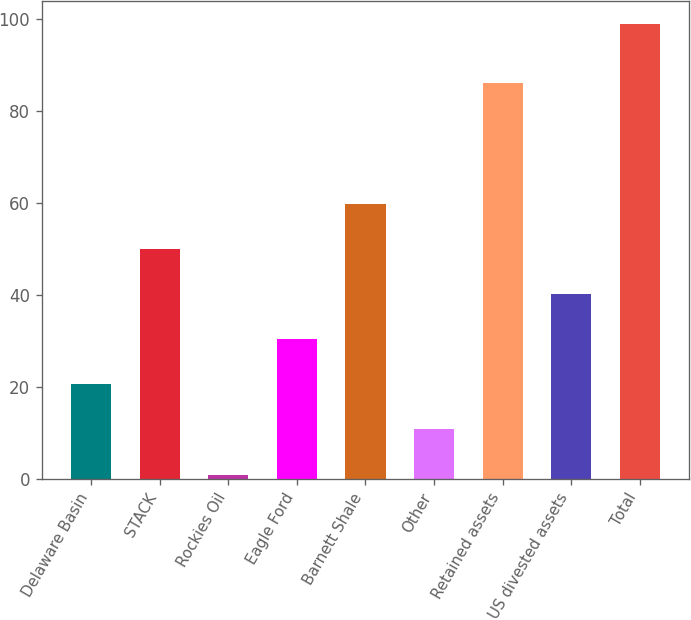Convert chart to OTSL. <chart><loc_0><loc_0><loc_500><loc_500><bar_chart><fcel>Delaware Basin<fcel>STACK<fcel>Rockies Oil<fcel>Eagle Ford<fcel>Barnett Shale<fcel>Other<fcel>Retained assets<fcel>US divested assets<fcel>Total<nl><fcel>20.6<fcel>50<fcel>1<fcel>30.4<fcel>59.8<fcel>10.8<fcel>86<fcel>40.2<fcel>99<nl></chart> 